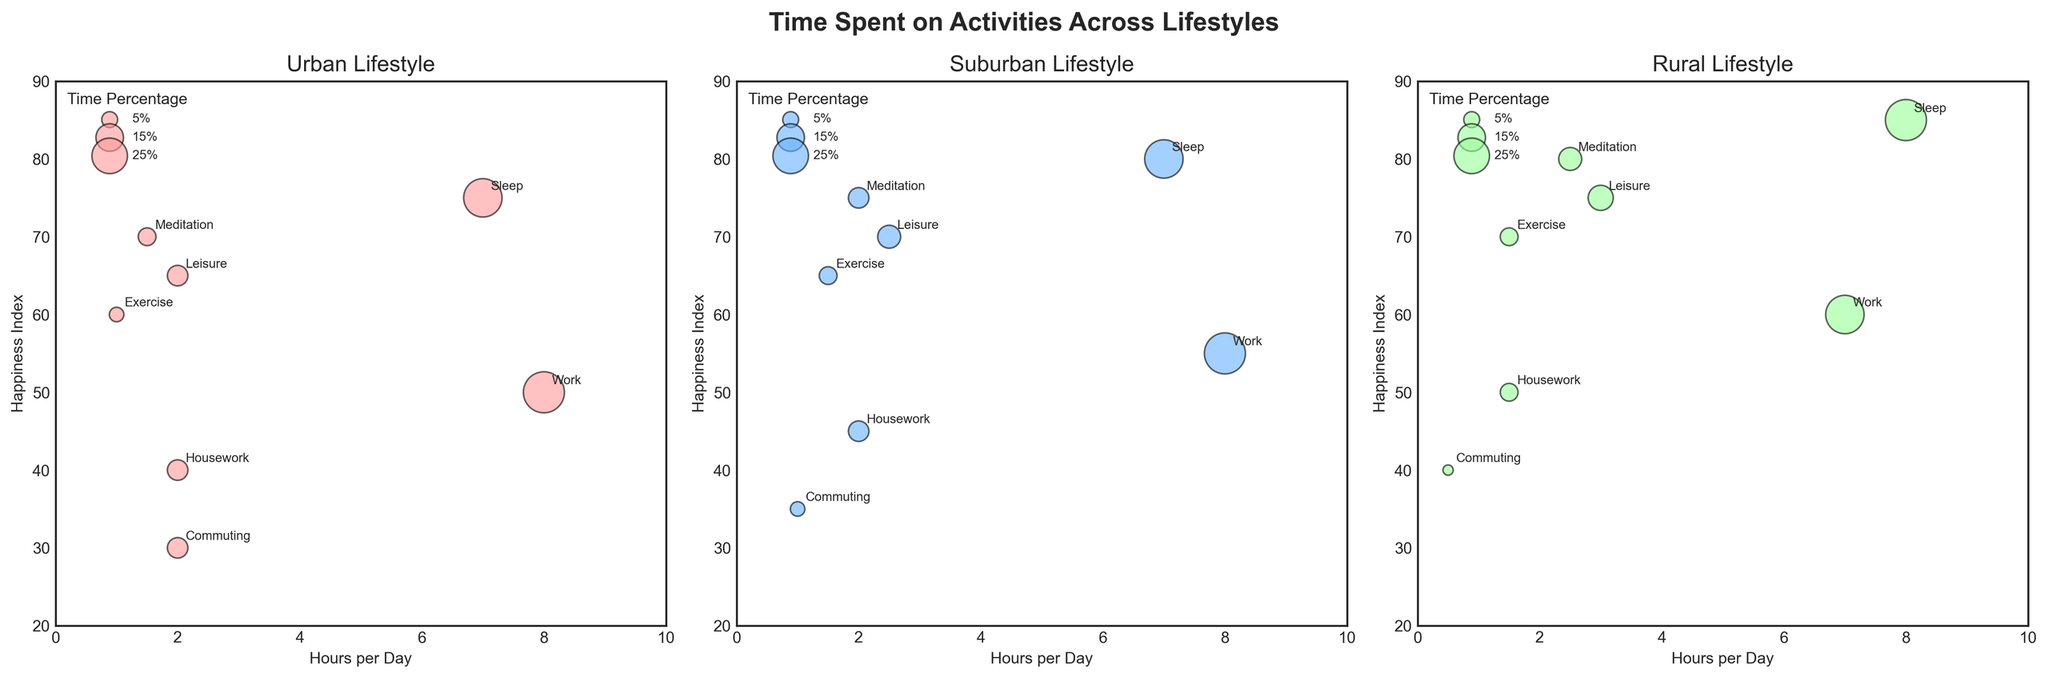How much time is spent meditating daily in an Urban lifestyle according to the figure? The plot shows that in the Urban lifestyle section, the bubble for Meditation is noted with 1.5 hours per day.
Answer: 1.5 hours How do the happiness indices for Meditation compare across the three lifestyles? In the Urban lifestyle, the happiness index for Meditation is 70. In the Suburban lifestyle, it's 75. In the Rural lifestyle, it's 80. Therefore, the happiness index for Meditation increases from Urban to Suburban to Rural.
Answer: Urban: 70, Suburban: 75, Rural: 80 Which lifestyle has the highest percentage of time spent on Leisure activities? The bubbles annotated "Leisure" show a percentage of 8.33% for Urban, 10.42% for Suburban, and 12.5% for Rural. Therefore, Rural lifestyle has the highest percentage of time spent on Leisure activities.
Answer: Rural Is sleep given more hours per day in the Urban or Rural lifestyle? According to the subplots under Urban and Rural lifestyles, Sleep has 7 hours per day for Urban and 8 hours per day for Rural, meaning sleep is given more hours in the Rural lifestyle.
Answer: Rural What is the bubble size for Meditation in the Suburban lifestyle? The percentage of time spent on Meditation in the Suburban lifestyle is 8.33%. Since the size of the bubbles represents the percentage multiplied by 20, the bubble size is 8.33 * 20 = 166.6.
Answer: 166.6 Which activity has the lowest happiness index in the Rural lifestyle? In the Rural lifestyle subplot, the smallest y-axis value (Happiness Index) corresponds to Commuting, with a Happiness Index of 40.
Answer: Commuting Compare the hours per day spent on Work between Suburban and Rural lifestyles. The Suburban subplot shows an 8-hour Workday, while the Rural subplot indicates 7 hours. Therefore, Suburban has more hours per day spent on Work than Rural.
Answer: Suburban (8 hours) vs Rural (7 hours) How many categories of activities are compared per lifestyle? Each subplot shows bubbles annotated with different activities, and counting these annotations in any one subplot will confirm that there are 7 categories of activities compared per lifestyle.
Answer: 7 Looking at the Urban lifestyle, which activity has the second-highest happiness index? In the Urban lifestyle subplot, Sleep has the highest happiness index of 75, and Leisure has the second-highest happiness index of 65.
Answer: Leisure 